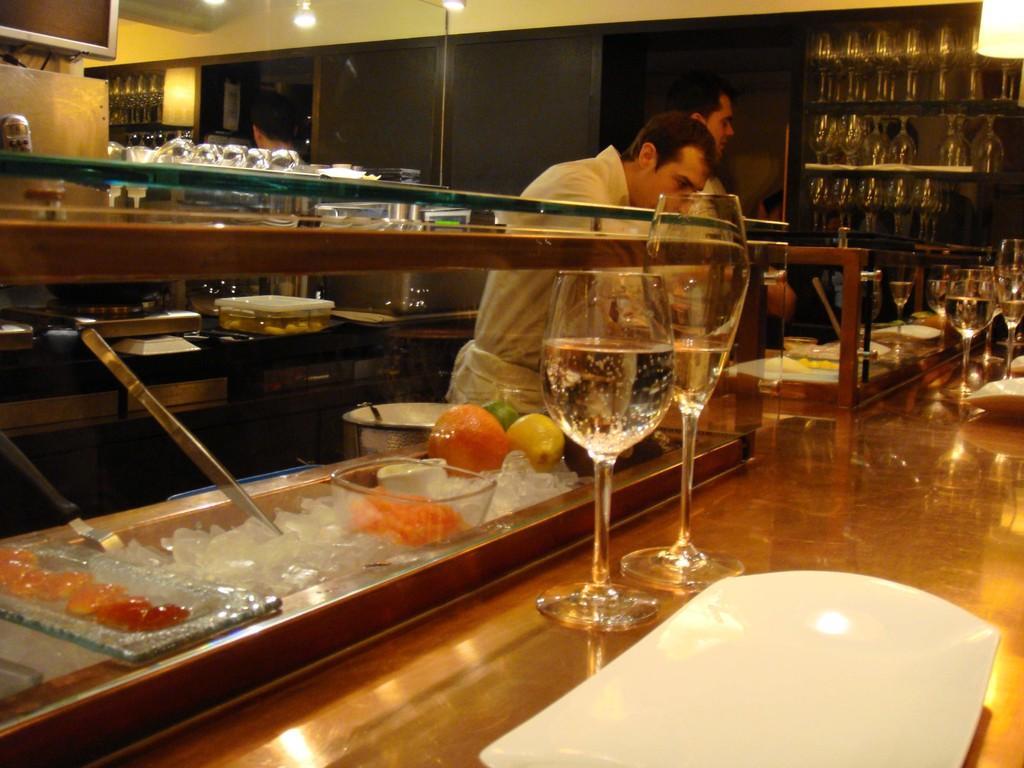Could you give a brief overview of what you see in this image? Here we can see two men are standing at the table. On the table we can see glasses,plate,ice cubes,fruits and food items. In the background we can see glasses on the racks and metal objects and on the mirror we can see the reflections of lights,wall,glasses and other objects. 